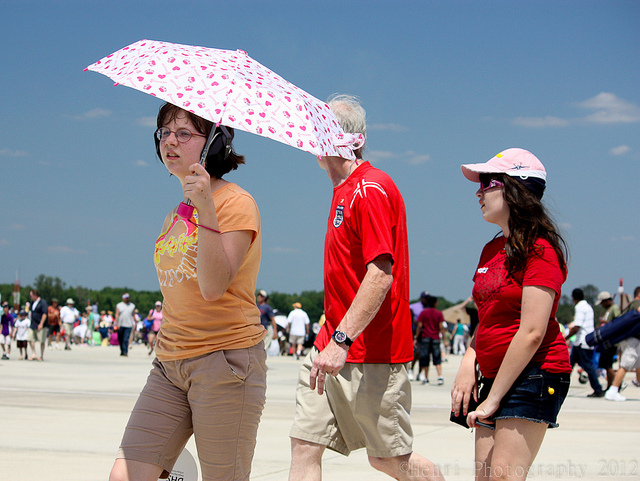Identify and read out the text in this image. 2012 Photography 